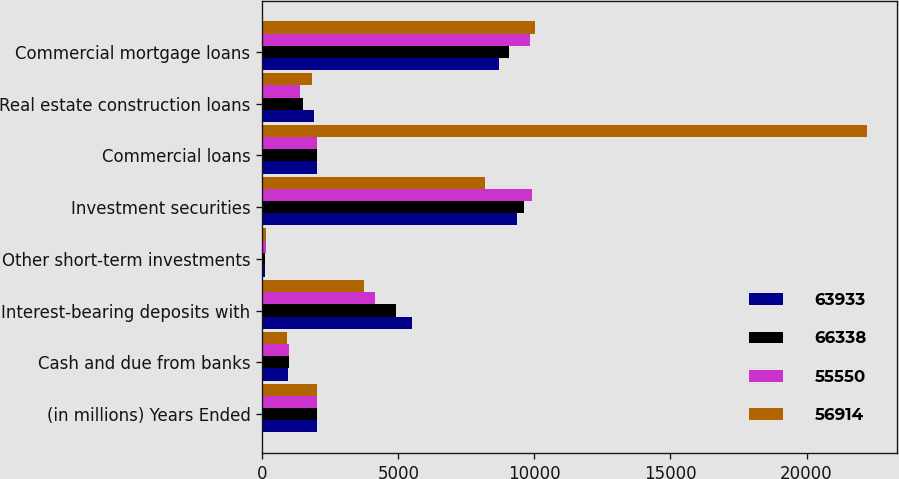Convert chart. <chart><loc_0><loc_0><loc_500><loc_500><stacked_bar_chart><ecel><fcel>(in millions) Years Ended<fcel>Cash and due from banks<fcel>Interest-bearing deposits with<fcel>Other short-term investments<fcel>Investment securities<fcel>Commercial loans<fcel>Real estate construction loans<fcel>Commercial mortgage loans<nl><fcel>63933<fcel>2014<fcel>934<fcel>5513<fcel>109<fcel>9350<fcel>2013<fcel>1909<fcel>8706<nl><fcel>66338<fcel>2013<fcel>987<fcel>4930<fcel>112<fcel>9637<fcel>2013<fcel>1486<fcel>9060<nl><fcel>55550<fcel>2012<fcel>983<fcel>4128<fcel>134<fcel>9915<fcel>2013<fcel>1390<fcel>9842<nl><fcel>56914<fcel>2011<fcel>921<fcel>3746<fcel>129<fcel>8171<fcel>22208<fcel>1843<fcel>10025<nl></chart> 